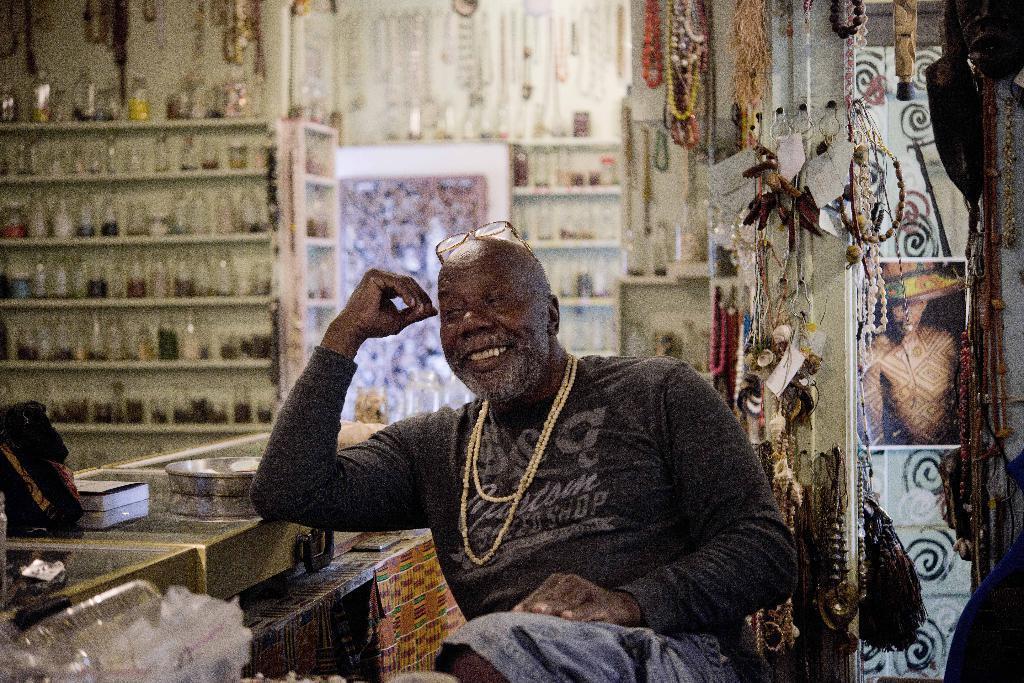Can you describe this image briefly? In the center of the image there is a person sitting on the chair. In the background of the image there are bottles arranged in a shelf. To the left side of the image there is a counter on which there are objects. To right side of the image there are objects on the wall. 